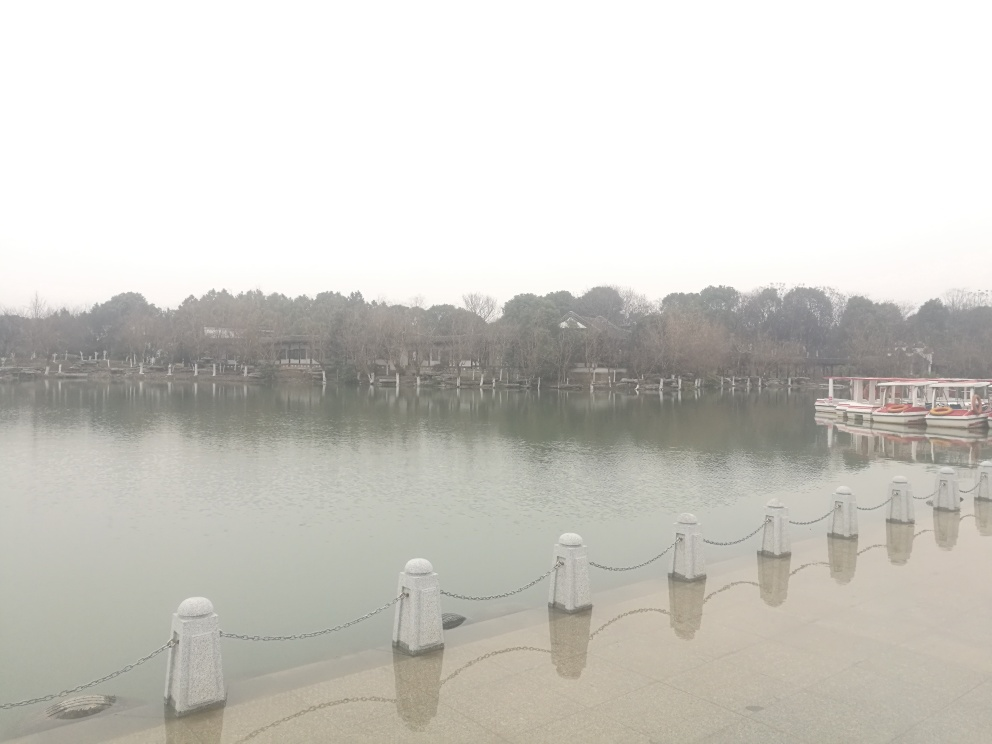What can you tell me about the weather conditions in this image? The sky appears overcast, suggesting either early morning fog, impending rain, or simply a cloudy day. The lighting is soft and there are no strong shadows, which reinforces the absence of direct sunlight. 